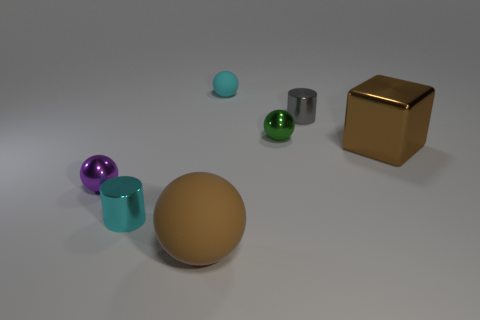There is another matte object that is the same shape as the big rubber object; what is its size?
Your answer should be compact. Small. The other rubber object that is the same shape as the big brown rubber thing is what color?
Keep it short and to the point. Cyan. There is a large thing that is the same color as the metal block; what shape is it?
Ensure brevity in your answer.  Sphere. What color is the metallic cube that is the same size as the brown matte ball?
Ensure brevity in your answer.  Brown. How many big things are metallic spheres or rubber balls?
Ensure brevity in your answer.  1. Are there more spheres left of the cyan rubber thing than green spheres on the left side of the brown metallic block?
Provide a succinct answer. Yes. The object that is the same color as the large shiny block is what size?
Offer a terse response. Large. How many other objects are there of the same size as the green ball?
Offer a very short reply. 4. Is the material of the tiny cyan thing that is behind the purple metallic sphere the same as the cyan cylinder?
Your response must be concise. No. How many other things are the same color as the large matte thing?
Provide a succinct answer. 1. 